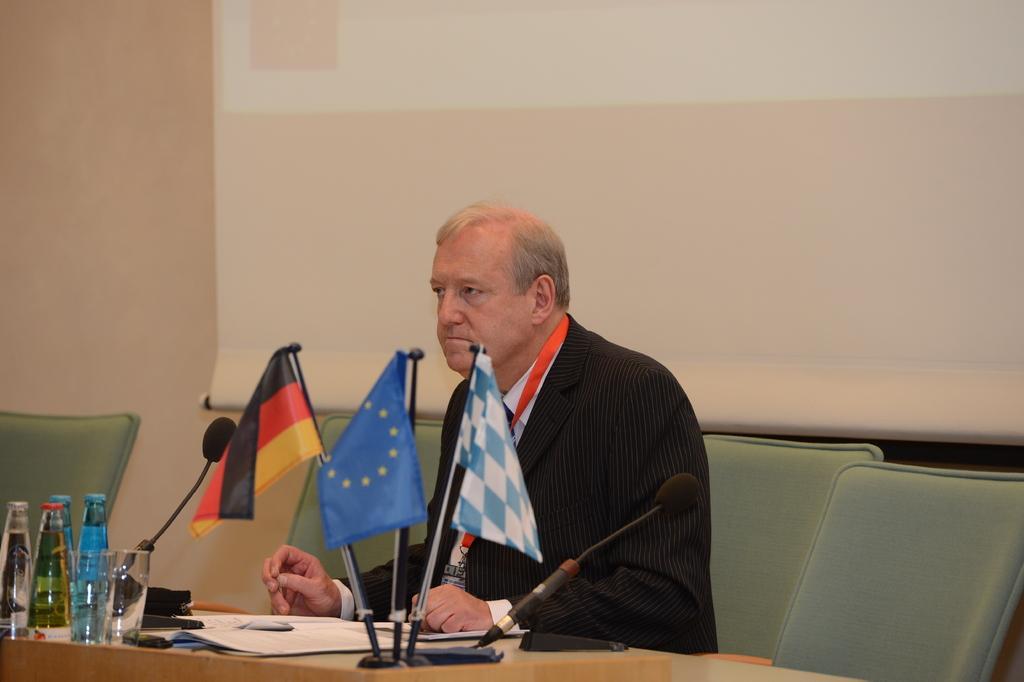In one or two sentences, can you explain what this image depicts? In this picture we can see a old man sitting on a chair, here we can see a microphone and there are couple of flags present on the table, there are some bottles and glasses placed on the table and behind him we can see projector screen 